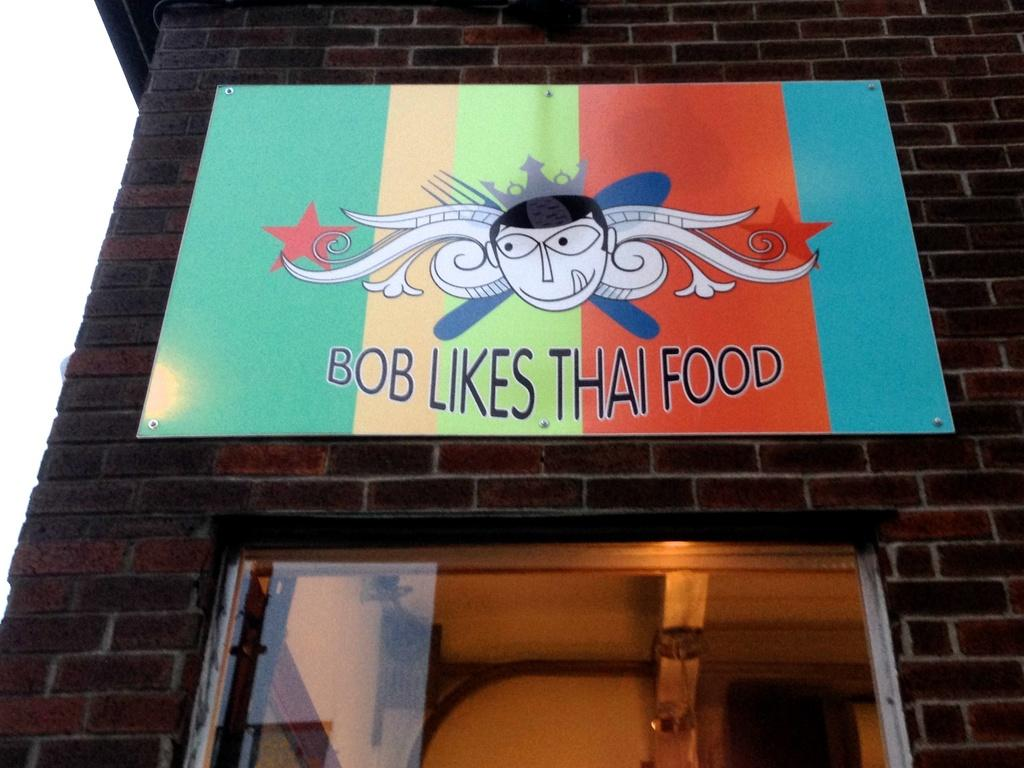What type of structure is visible in the image? There is a building in the image. Can you describe any specific features of the building? There is a door in the image. Is there any additional information on the building? Yes, there is a board on the building with something written on it. What type of fuel is being used by the circle in the image? There is no circle present in the image, and therefore no fuel can be associated with it. 